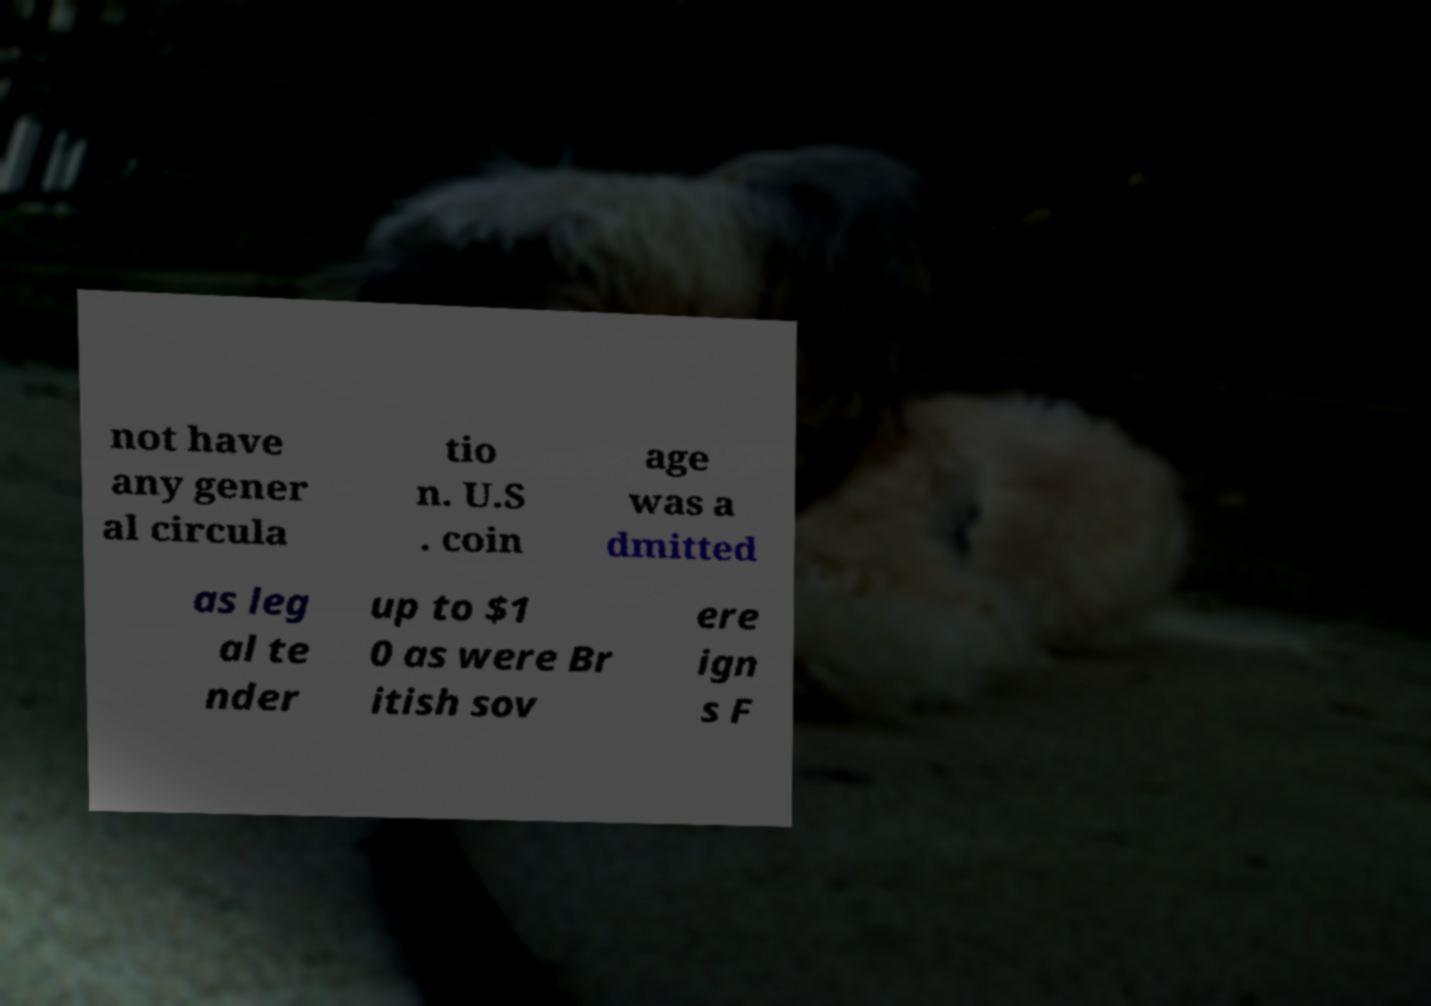Can you accurately transcribe the text from the provided image for me? not have any gener al circula tio n. U.S . coin age was a dmitted as leg al te nder up to $1 0 as were Br itish sov ere ign s F 